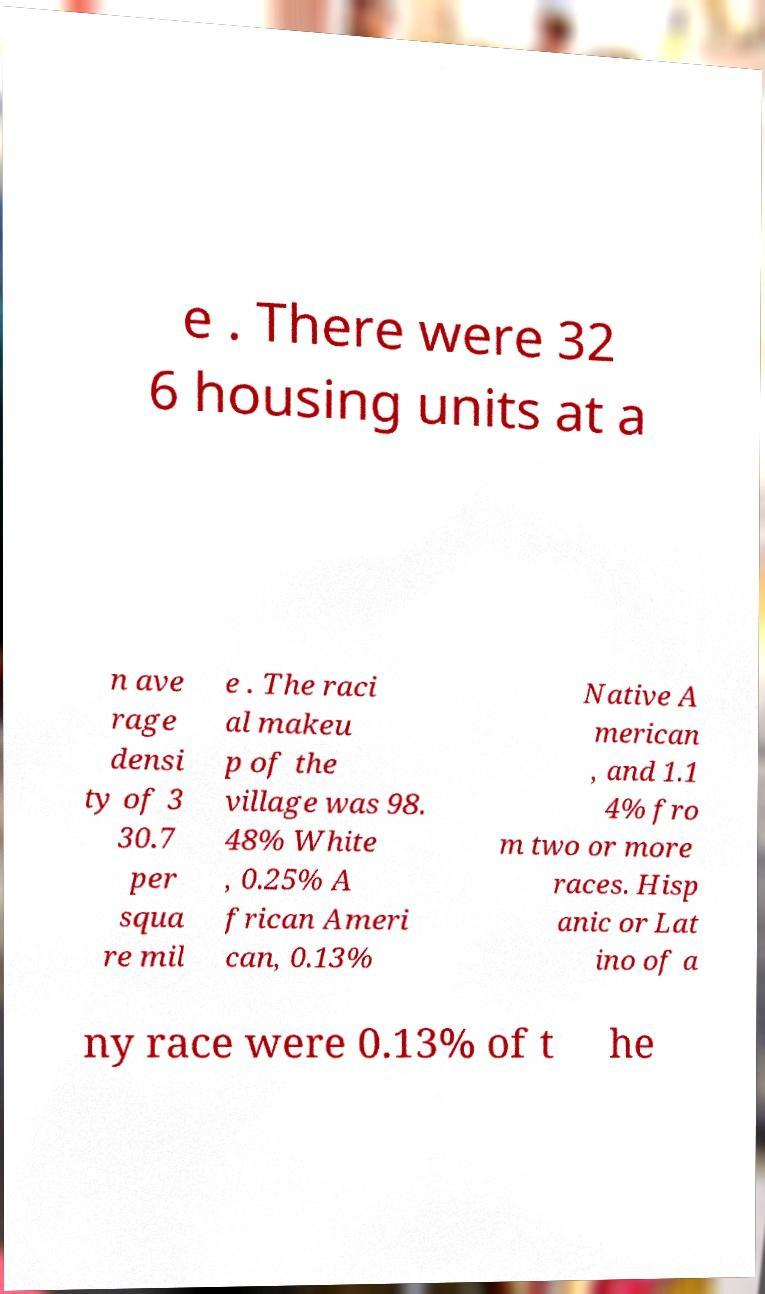Can you read and provide the text displayed in the image?This photo seems to have some interesting text. Can you extract and type it out for me? e . There were 32 6 housing units at a n ave rage densi ty of 3 30.7 per squa re mil e . The raci al makeu p of the village was 98. 48% White , 0.25% A frican Ameri can, 0.13% Native A merican , and 1.1 4% fro m two or more races. Hisp anic or Lat ino of a ny race were 0.13% of t he 